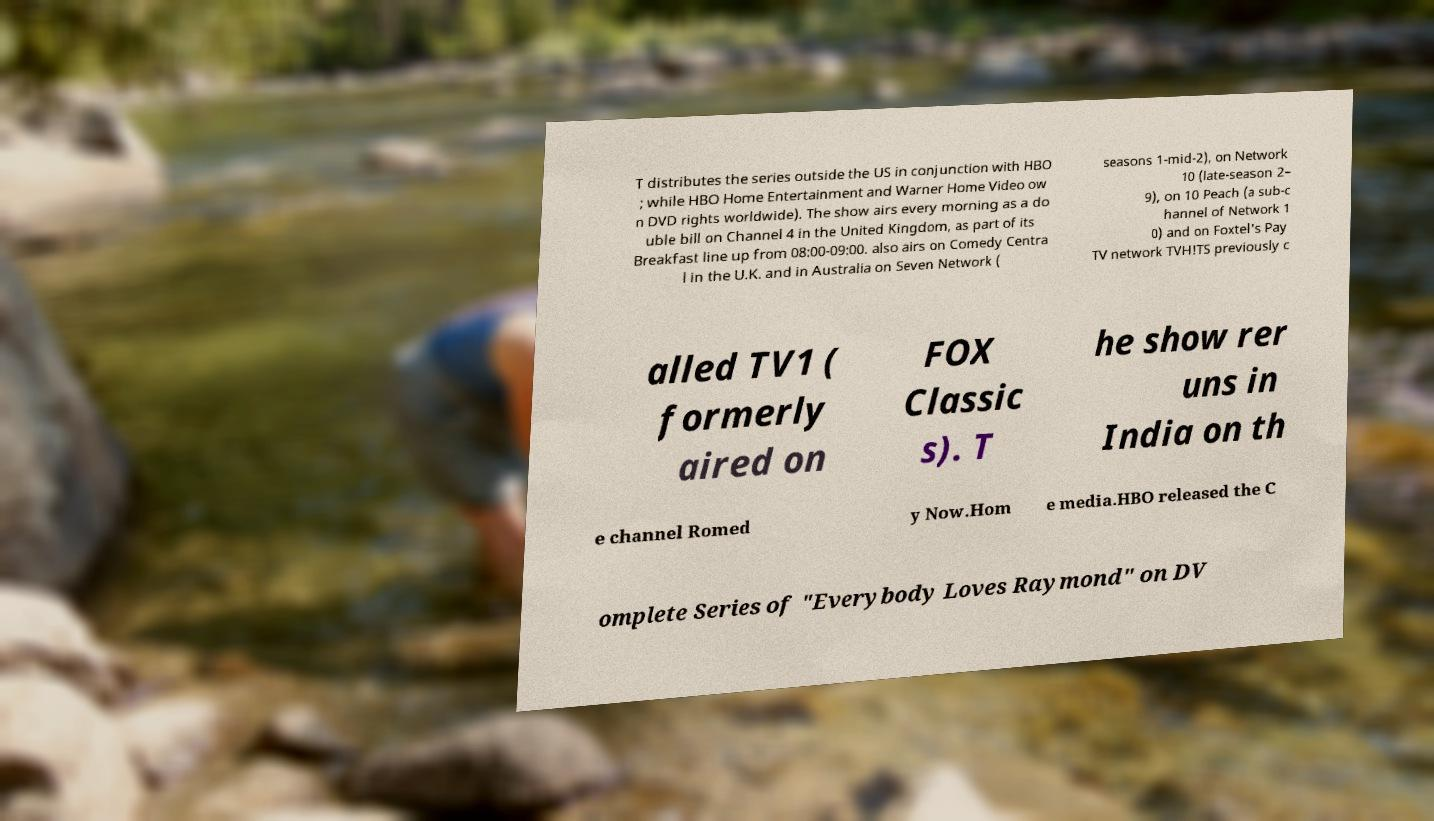What messages or text are displayed in this image? I need them in a readable, typed format. T distributes the series outside the US in conjunction with HBO ; while HBO Home Entertainment and Warner Home Video ow n DVD rights worldwide). The show airs every morning as a do uble bill on Channel 4 in the United Kingdom, as part of its Breakfast line up from 08:00-09:00. also airs on Comedy Centra l in the U.K. and in Australia on Seven Network ( seasons 1-mid-2), on Network 10 (late-season 2– 9), on 10 Peach (a sub-c hannel of Network 1 0) and on Foxtel's Pay TV network TVH!TS previously c alled TV1 ( formerly aired on FOX Classic s). T he show rer uns in India on th e channel Romed y Now.Hom e media.HBO released the C omplete Series of "Everybody Loves Raymond" on DV 